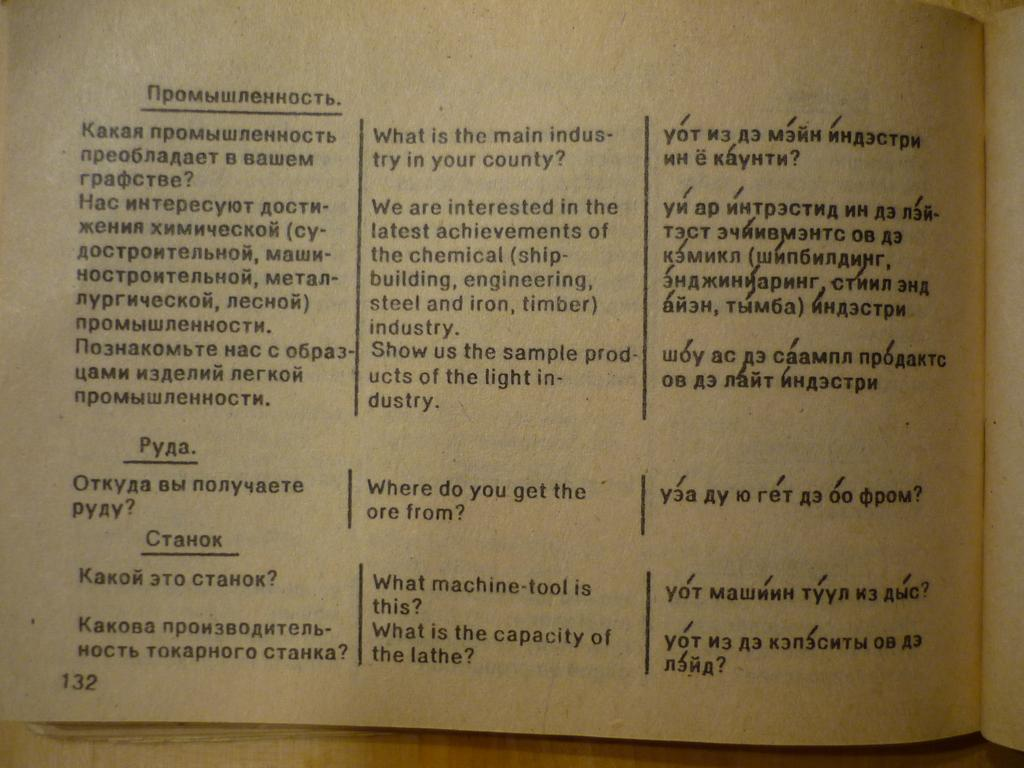<image>
Present a compact description of the photo's key features. The first question at the top of the page asks what is the main industry in your country. 